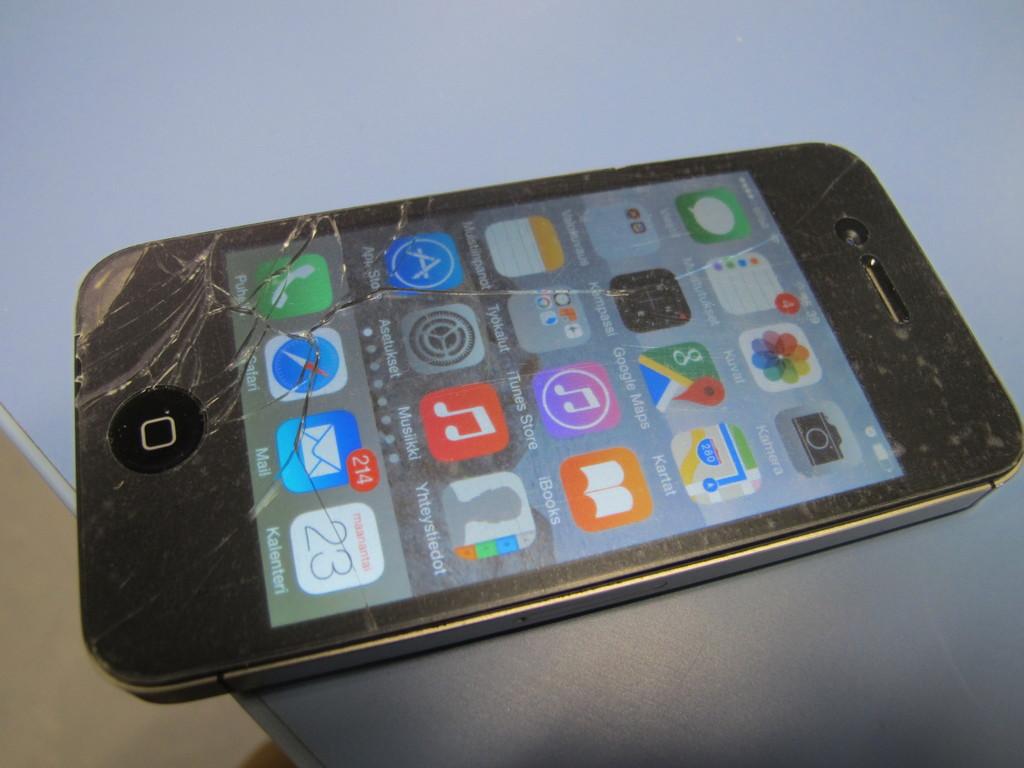How much unread mail messages are there?
Ensure brevity in your answer.  214. What is the name of one of the apps shown on the phone?
Ensure brevity in your answer.  Mail. 